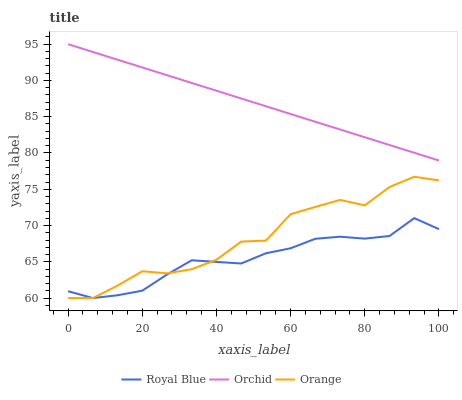Does Royal Blue have the minimum area under the curve?
Answer yes or no. Yes. Does Orchid have the maximum area under the curve?
Answer yes or no. Yes. Does Orchid have the minimum area under the curve?
Answer yes or no. No. Does Royal Blue have the maximum area under the curve?
Answer yes or no. No. Is Orchid the smoothest?
Answer yes or no. Yes. Is Orange the roughest?
Answer yes or no. Yes. Is Royal Blue the smoothest?
Answer yes or no. No. Is Royal Blue the roughest?
Answer yes or no. No. Does Orchid have the lowest value?
Answer yes or no. No. Does Orchid have the highest value?
Answer yes or no. Yes. Does Royal Blue have the highest value?
Answer yes or no. No. Is Royal Blue less than Orchid?
Answer yes or no. Yes. Is Orchid greater than Royal Blue?
Answer yes or no. Yes. Does Orange intersect Royal Blue?
Answer yes or no. Yes. Is Orange less than Royal Blue?
Answer yes or no. No. Is Orange greater than Royal Blue?
Answer yes or no. No. Does Royal Blue intersect Orchid?
Answer yes or no. No. 